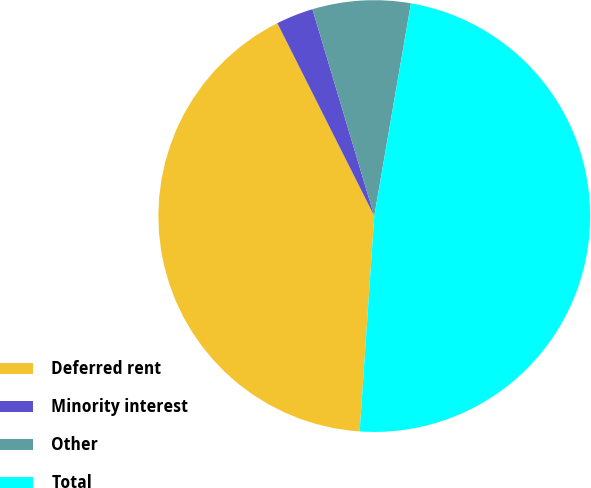Convert chart. <chart><loc_0><loc_0><loc_500><loc_500><pie_chart><fcel>Deferred rent<fcel>Minority interest<fcel>Other<fcel>Total<nl><fcel>41.51%<fcel>2.79%<fcel>7.34%<fcel>48.36%<nl></chart> 